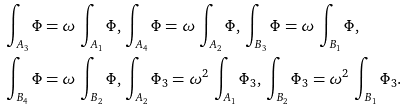Convert formula to latex. <formula><loc_0><loc_0><loc_500><loc_500>\int _ { A _ { 3 } } \Phi & = \omega \, \int _ { A _ { 1 } } \Phi , \, \int _ { A _ { 4 } } \Phi = \omega \, \int _ { A _ { 2 } } \Phi , \, \int _ { B _ { 3 } } \Phi = \omega \, \int _ { B _ { 1 } } \Phi , \\ \int _ { B _ { 4 } } \Phi & = \omega \, \int _ { B _ { 2 } } \Phi , \, \int _ { A _ { 2 } } \Phi _ { 3 } = \omega ^ { 2 } \, \int _ { A _ { 1 } } \Phi _ { 3 } , \, \int _ { B _ { 2 } } \Phi _ { 3 } = \omega ^ { 2 } \, \int _ { B _ { 1 } } \Phi _ { 3 } .</formula> 